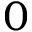Convert formula to latex. <formula><loc_0><loc_0><loc_500><loc_500>0</formula> 